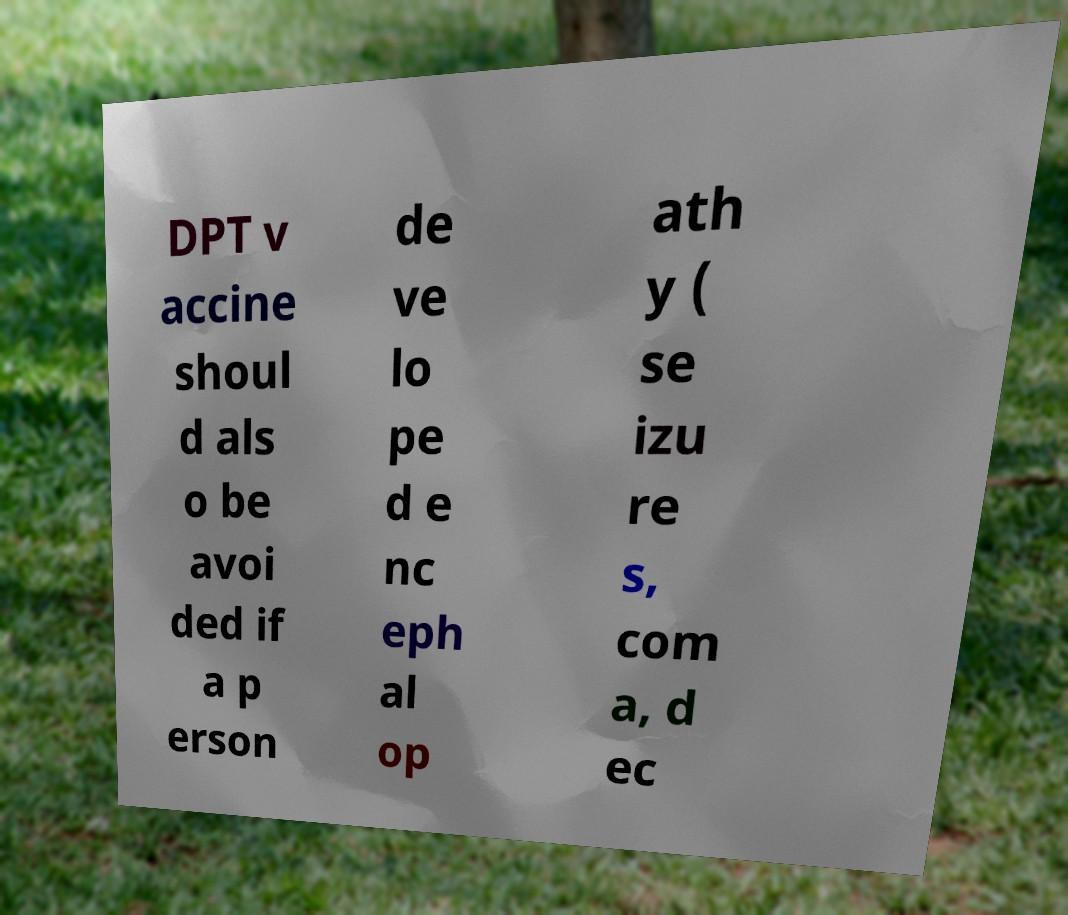Please read and relay the text visible in this image. What does it say? DPT v accine shoul d als o be avoi ded if a p erson de ve lo pe d e nc eph al op ath y ( se izu re s, com a, d ec 